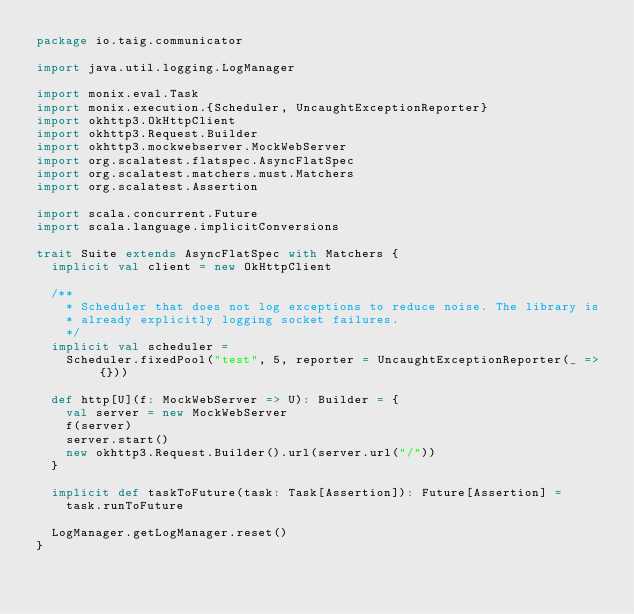<code> <loc_0><loc_0><loc_500><loc_500><_Scala_>package io.taig.communicator

import java.util.logging.LogManager

import monix.eval.Task
import monix.execution.{Scheduler, UncaughtExceptionReporter}
import okhttp3.OkHttpClient
import okhttp3.Request.Builder
import okhttp3.mockwebserver.MockWebServer
import org.scalatest.flatspec.AsyncFlatSpec
import org.scalatest.matchers.must.Matchers
import org.scalatest.Assertion

import scala.concurrent.Future
import scala.language.implicitConversions

trait Suite extends AsyncFlatSpec with Matchers {
  implicit val client = new OkHttpClient

  /**
    * Scheduler that does not log exceptions to reduce noise. The library is
    * already explicitly logging socket failures.
    */
  implicit val scheduler =
    Scheduler.fixedPool("test", 5, reporter = UncaughtExceptionReporter(_ => {}))

  def http[U](f: MockWebServer => U): Builder = {
    val server = new MockWebServer
    f(server)
    server.start()
    new okhttp3.Request.Builder().url(server.url("/"))
  }

  implicit def taskToFuture(task: Task[Assertion]): Future[Assertion] =
    task.runToFuture

  LogManager.getLogManager.reset()
}
</code> 